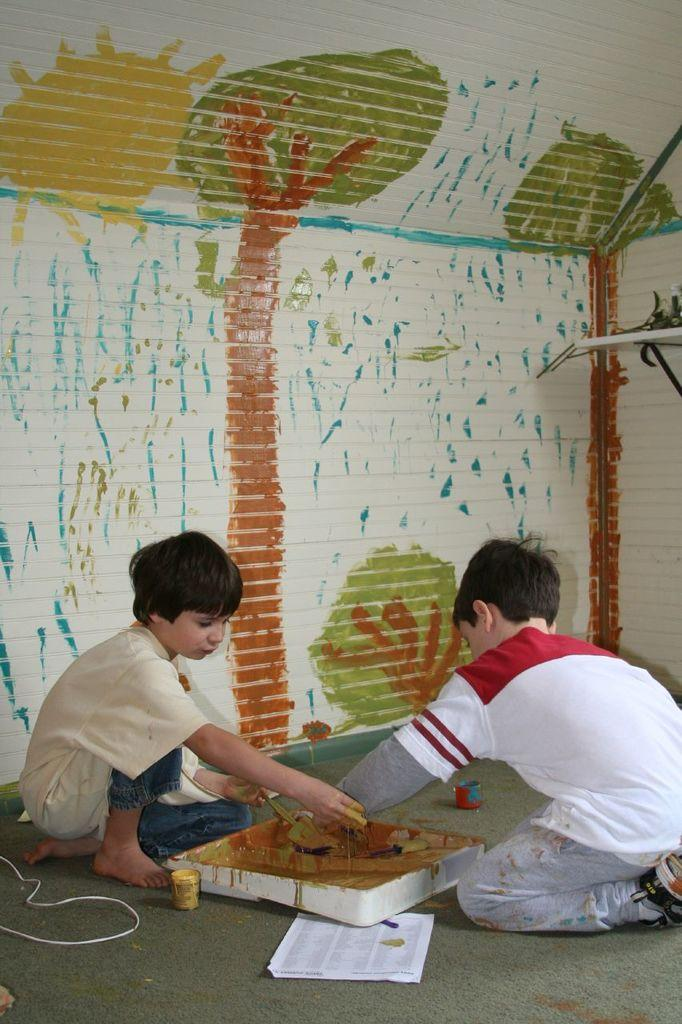How many children are in the image? There are two children in the image. What are the children doing in the image? The children are playing with paints. What is the surface beneath the children in the image? There is a floor at the bottom of the image. What can be seen in the background of the image? There is a wall in the background of the image. What is on the wall in the image? Paintings are present on the wall. What type of bubble is floating near the children in the image? There is no bubble present in the image; the children are playing with paints. Are the children in the image part of an army? There is no indication in the image that the children are part of an army. 